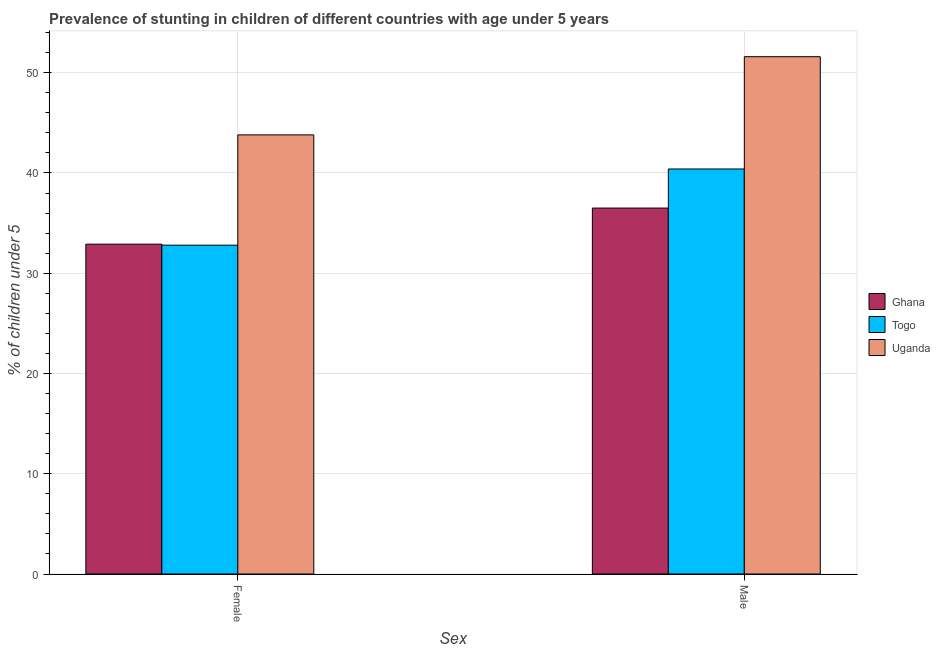How many bars are there on the 2nd tick from the left?
Ensure brevity in your answer.  3. How many bars are there on the 1st tick from the right?
Your answer should be compact. 3. What is the percentage of stunted female children in Uganda?
Keep it short and to the point. 43.8. Across all countries, what is the maximum percentage of stunted male children?
Provide a short and direct response. 51.6. Across all countries, what is the minimum percentage of stunted male children?
Your answer should be compact. 36.5. In which country was the percentage of stunted male children maximum?
Ensure brevity in your answer.  Uganda. What is the total percentage of stunted female children in the graph?
Your response must be concise. 109.5. What is the difference between the percentage of stunted female children in Ghana and the percentage of stunted male children in Togo?
Your answer should be very brief. -7.5. What is the average percentage of stunted female children per country?
Your response must be concise. 36.5. What is the difference between the percentage of stunted female children and percentage of stunted male children in Ghana?
Provide a succinct answer. -3.6. What is the ratio of the percentage of stunted male children in Ghana to that in Uganda?
Ensure brevity in your answer.  0.71. In how many countries, is the percentage of stunted female children greater than the average percentage of stunted female children taken over all countries?
Provide a short and direct response. 1. What does the 1st bar from the right in Female represents?
Keep it short and to the point. Uganda. How many countries are there in the graph?
Provide a short and direct response. 3. Does the graph contain any zero values?
Give a very brief answer. No. Where does the legend appear in the graph?
Give a very brief answer. Center right. How many legend labels are there?
Give a very brief answer. 3. What is the title of the graph?
Keep it short and to the point. Prevalence of stunting in children of different countries with age under 5 years. What is the label or title of the X-axis?
Provide a succinct answer. Sex. What is the label or title of the Y-axis?
Keep it short and to the point.  % of children under 5. What is the  % of children under 5 of Ghana in Female?
Offer a very short reply. 32.9. What is the  % of children under 5 of Togo in Female?
Offer a terse response. 32.8. What is the  % of children under 5 in Uganda in Female?
Ensure brevity in your answer.  43.8. What is the  % of children under 5 of Ghana in Male?
Offer a terse response. 36.5. What is the  % of children under 5 of Togo in Male?
Ensure brevity in your answer.  40.4. What is the  % of children under 5 in Uganda in Male?
Your answer should be very brief. 51.6. Across all Sex, what is the maximum  % of children under 5 in Ghana?
Your answer should be compact. 36.5. Across all Sex, what is the maximum  % of children under 5 of Togo?
Make the answer very short. 40.4. Across all Sex, what is the maximum  % of children under 5 in Uganda?
Give a very brief answer. 51.6. Across all Sex, what is the minimum  % of children under 5 of Ghana?
Your answer should be compact. 32.9. Across all Sex, what is the minimum  % of children under 5 of Togo?
Offer a terse response. 32.8. Across all Sex, what is the minimum  % of children under 5 of Uganda?
Offer a terse response. 43.8. What is the total  % of children under 5 in Ghana in the graph?
Your answer should be very brief. 69.4. What is the total  % of children under 5 of Togo in the graph?
Your answer should be very brief. 73.2. What is the total  % of children under 5 in Uganda in the graph?
Provide a short and direct response. 95.4. What is the difference between the  % of children under 5 in Ghana in Female and that in Male?
Your response must be concise. -3.6. What is the difference between the  % of children under 5 in Togo in Female and that in Male?
Your answer should be compact. -7.6. What is the difference between the  % of children under 5 of Ghana in Female and the  % of children under 5 of Uganda in Male?
Keep it short and to the point. -18.7. What is the difference between the  % of children under 5 of Togo in Female and the  % of children under 5 of Uganda in Male?
Your response must be concise. -18.8. What is the average  % of children under 5 in Ghana per Sex?
Your answer should be very brief. 34.7. What is the average  % of children under 5 of Togo per Sex?
Keep it short and to the point. 36.6. What is the average  % of children under 5 in Uganda per Sex?
Keep it short and to the point. 47.7. What is the difference between the  % of children under 5 in Ghana and  % of children under 5 in Togo in Female?
Provide a succinct answer. 0.1. What is the difference between the  % of children under 5 of Togo and  % of children under 5 of Uganda in Female?
Your answer should be very brief. -11. What is the difference between the  % of children under 5 in Ghana and  % of children under 5 in Uganda in Male?
Give a very brief answer. -15.1. What is the difference between the  % of children under 5 in Togo and  % of children under 5 in Uganda in Male?
Your response must be concise. -11.2. What is the ratio of the  % of children under 5 of Ghana in Female to that in Male?
Provide a succinct answer. 0.9. What is the ratio of the  % of children under 5 in Togo in Female to that in Male?
Your response must be concise. 0.81. What is the ratio of the  % of children under 5 in Uganda in Female to that in Male?
Ensure brevity in your answer.  0.85. What is the difference between the highest and the lowest  % of children under 5 of Togo?
Provide a succinct answer. 7.6. What is the difference between the highest and the lowest  % of children under 5 in Uganda?
Keep it short and to the point. 7.8. 